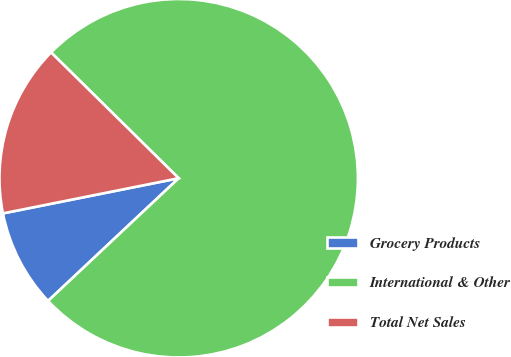Convert chart. <chart><loc_0><loc_0><loc_500><loc_500><pie_chart><fcel>Grocery Products<fcel>International & Other<fcel>Total Net Sales<nl><fcel>8.86%<fcel>75.61%<fcel>15.53%<nl></chart> 